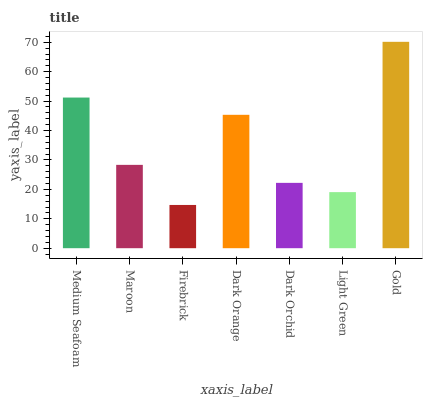Is Firebrick the minimum?
Answer yes or no. Yes. Is Gold the maximum?
Answer yes or no. Yes. Is Maroon the minimum?
Answer yes or no. No. Is Maroon the maximum?
Answer yes or no. No. Is Medium Seafoam greater than Maroon?
Answer yes or no. Yes. Is Maroon less than Medium Seafoam?
Answer yes or no. Yes. Is Maroon greater than Medium Seafoam?
Answer yes or no. No. Is Medium Seafoam less than Maroon?
Answer yes or no. No. Is Maroon the high median?
Answer yes or no. Yes. Is Maroon the low median?
Answer yes or no. Yes. Is Dark Orchid the high median?
Answer yes or no. No. Is Dark Orchid the low median?
Answer yes or no. No. 